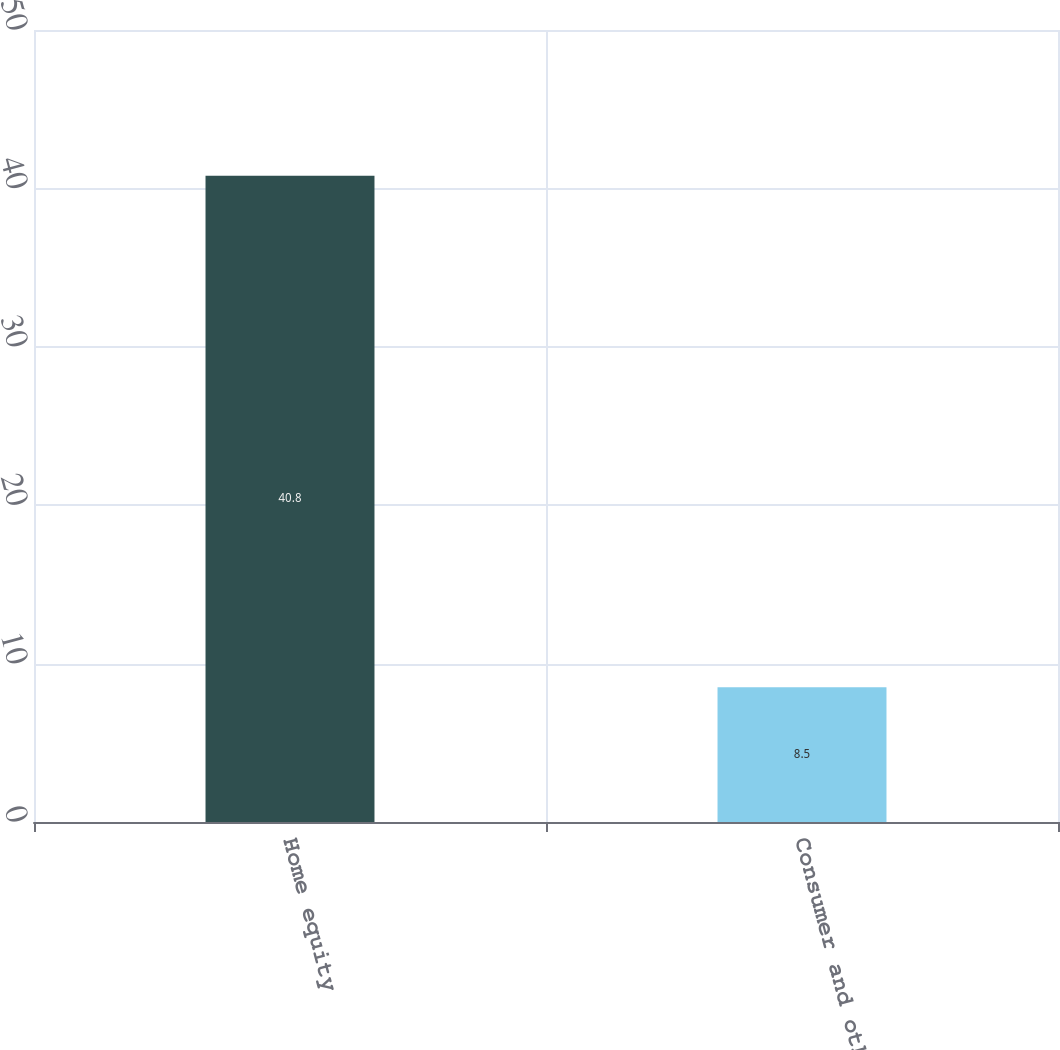Convert chart to OTSL. <chart><loc_0><loc_0><loc_500><loc_500><bar_chart><fcel>Home equity<fcel>Consumer and other<nl><fcel>40.8<fcel>8.5<nl></chart> 